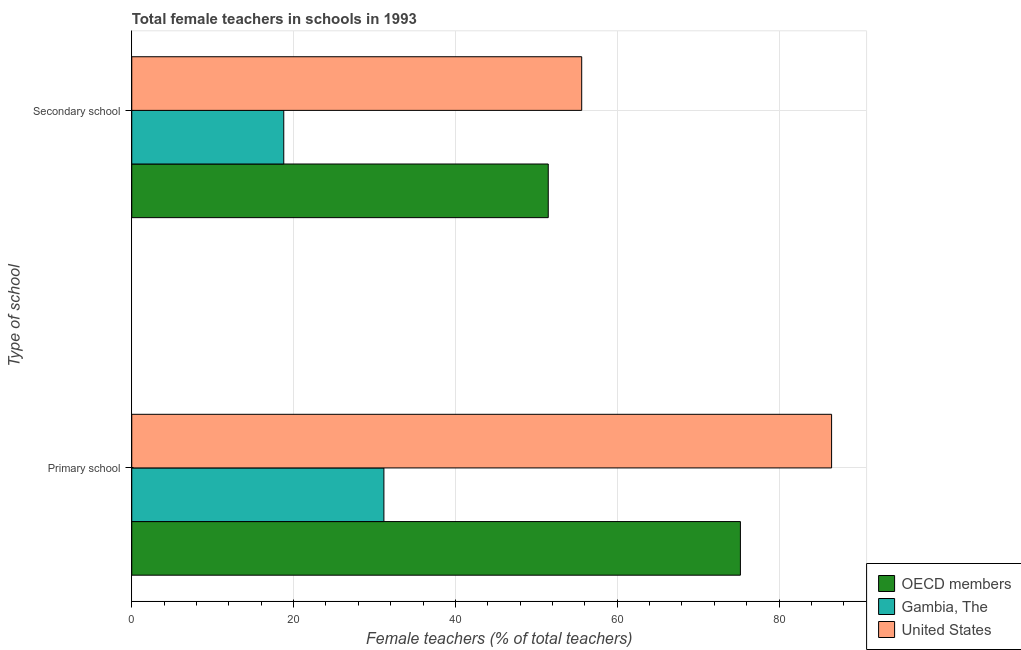How many different coloured bars are there?
Offer a terse response. 3. Are the number of bars per tick equal to the number of legend labels?
Ensure brevity in your answer.  Yes. How many bars are there on the 2nd tick from the bottom?
Offer a very short reply. 3. What is the label of the 1st group of bars from the top?
Provide a short and direct response. Secondary school. What is the percentage of female teachers in secondary schools in Gambia, The?
Make the answer very short. 18.79. Across all countries, what is the maximum percentage of female teachers in secondary schools?
Ensure brevity in your answer.  55.61. Across all countries, what is the minimum percentage of female teachers in primary schools?
Ensure brevity in your answer.  31.16. In which country was the percentage of female teachers in secondary schools maximum?
Provide a succinct answer. United States. In which country was the percentage of female teachers in primary schools minimum?
Offer a terse response. Gambia, The. What is the total percentage of female teachers in secondary schools in the graph?
Your answer should be very brief. 125.87. What is the difference between the percentage of female teachers in primary schools in United States and that in Gambia, The?
Your answer should be compact. 55.33. What is the difference between the percentage of female teachers in primary schools in OECD members and the percentage of female teachers in secondary schools in Gambia, The?
Your response must be concise. 56.44. What is the average percentage of female teachers in primary schools per country?
Ensure brevity in your answer.  64.29. What is the difference between the percentage of female teachers in primary schools and percentage of female teachers in secondary schools in OECD members?
Provide a succinct answer. 23.75. What is the ratio of the percentage of female teachers in secondary schools in OECD members to that in Gambia, The?
Your answer should be very brief. 2.74. What does the 1st bar from the top in Secondary school represents?
Offer a very short reply. United States. Are all the bars in the graph horizontal?
Your answer should be compact. Yes. What is the difference between two consecutive major ticks on the X-axis?
Provide a succinct answer. 20. Are the values on the major ticks of X-axis written in scientific E-notation?
Offer a terse response. No. Does the graph contain grids?
Offer a very short reply. Yes. Where does the legend appear in the graph?
Your answer should be compact. Bottom right. How many legend labels are there?
Your answer should be very brief. 3. How are the legend labels stacked?
Provide a succinct answer. Vertical. What is the title of the graph?
Your answer should be compact. Total female teachers in schools in 1993. Does "Japan" appear as one of the legend labels in the graph?
Offer a very short reply. No. What is the label or title of the X-axis?
Offer a very short reply. Female teachers (% of total teachers). What is the label or title of the Y-axis?
Give a very brief answer. Type of school. What is the Female teachers (% of total teachers) of OECD members in Primary school?
Your response must be concise. 75.22. What is the Female teachers (% of total teachers) of Gambia, The in Primary school?
Your response must be concise. 31.16. What is the Female teachers (% of total teachers) in United States in Primary school?
Your response must be concise. 86.49. What is the Female teachers (% of total teachers) in OECD members in Secondary school?
Provide a succinct answer. 51.47. What is the Female teachers (% of total teachers) of Gambia, The in Secondary school?
Offer a terse response. 18.79. What is the Female teachers (% of total teachers) of United States in Secondary school?
Your answer should be very brief. 55.61. Across all Type of school, what is the maximum Female teachers (% of total teachers) of OECD members?
Offer a very short reply. 75.22. Across all Type of school, what is the maximum Female teachers (% of total teachers) of Gambia, The?
Make the answer very short. 31.16. Across all Type of school, what is the maximum Female teachers (% of total teachers) in United States?
Offer a very short reply. 86.49. Across all Type of school, what is the minimum Female teachers (% of total teachers) in OECD members?
Offer a terse response. 51.47. Across all Type of school, what is the minimum Female teachers (% of total teachers) in Gambia, The?
Your answer should be very brief. 18.79. Across all Type of school, what is the minimum Female teachers (% of total teachers) of United States?
Offer a very short reply. 55.61. What is the total Female teachers (% of total teachers) of OECD members in the graph?
Ensure brevity in your answer.  126.7. What is the total Female teachers (% of total teachers) of Gambia, The in the graph?
Offer a terse response. 49.95. What is the total Female teachers (% of total teachers) in United States in the graph?
Provide a short and direct response. 142.1. What is the difference between the Female teachers (% of total teachers) in OECD members in Primary school and that in Secondary school?
Your response must be concise. 23.75. What is the difference between the Female teachers (% of total teachers) in Gambia, The in Primary school and that in Secondary school?
Your answer should be compact. 12.38. What is the difference between the Female teachers (% of total teachers) of United States in Primary school and that in Secondary school?
Provide a succinct answer. 30.88. What is the difference between the Female teachers (% of total teachers) in OECD members in Primary school and the Female teachers (% of total teachers) in Gambia, The in Secondary school?
Ensure brevity in your answer.  56.44. What is the difference between the Female teachers (% of total teachers) of OECD members in Primary school and the Female teachers (% of total teachers) of United States in Secondary school?
Offer a terse response. 19.61. What is the difference between the Female teachers (% of total teachers) of Gambia, The in Primary school and the Female teachers (% of total teachers) of United States in Secondary school?
Your answer should be compact. -24.45. What is the average Female teachers (% of total teachers) in OECD members per Type of school?
Ensure brevity in your answer.  63.35. What is the average Female teachers (% of total teachers) of Gambia, The per Type of school?
Give a very brief answer. 24.97. What is the average Female teachers (% of total teachers) of United States per Type of school?
Keep it short and to the point. 71.05. What is the difference between the Female teachers (% of total teachers) of OECD members and Female teachers (% of total teachers) of Gambia, The in Primary school?
Provide a succinct answer. 44.06. What is the difference between the Female teachers (% of total teachers) of OECD members and Female teachers (% of total teachers) of United States in Primary school?
Your answer should be very brief. -11.27. What is the difference between the Female teachers (% of total teachers) in Gambia, The and Female teachers (% of total teachers) in United States in Primary school?
Provide a succinct answer. -55.33. What is the difference between the Female teachers (% of total teachers) in OECD members and Female teachers (% of total teachers) in Gambia, The in Secondary school?
Give a very brief answer. 32.69. What is the difference between the Female teachers (% of total teachers) of OECD members and Female teachers (% of total teachers) of United States in Secondary school?
Provide a short and direct response. -4.13. What is the difference between the Female teachers (% of total teachers) of Gambia, The and Female teachers (% of total teachers) of United States in Secondary school?
Your response must be concise. -36.82. What is the ratio of the Female teachers (% of total teachers) of OECD members in Primary school to that in Secondary school?
Your answer should be compact. 1.46. What is the ratio of the Female teachers (% of total teachers) in Gambia, The in Primary school to that in Secondary school?
Keep it short and to the point. 1.66. What is the ratio of the Female teachers (% of total teachers) of United States in Primary school to that in Secondary school?
Offer a terse response. 1.56. What is the difference between the highest and the second highest Female teachers (% of total teachers) of OECD members?
Your response must be concise. 23.75. What is the difference between the highest and the second highest Female teachers (% of total teachers) in Gambia, The?
Keep it short and to the point. 12.38. What is the difference between the highest and the second highest Female teachers (% of total teachers) in United States?
Make the answer very short. 30.88. What is the difference between the highest and the lowest Female teachers (% of total teachers) of OECD members?
Your answer should be very brief. 23.75. What is the difference between the highest and the lowest Female teachers (% of total teachers) in Gambia, The?
Provide a succinct answer. 12.38. What is the difference between the highest and the lowest Female teachers (% of total teachers) in United States?
Offer a very short reply. 30.88. 